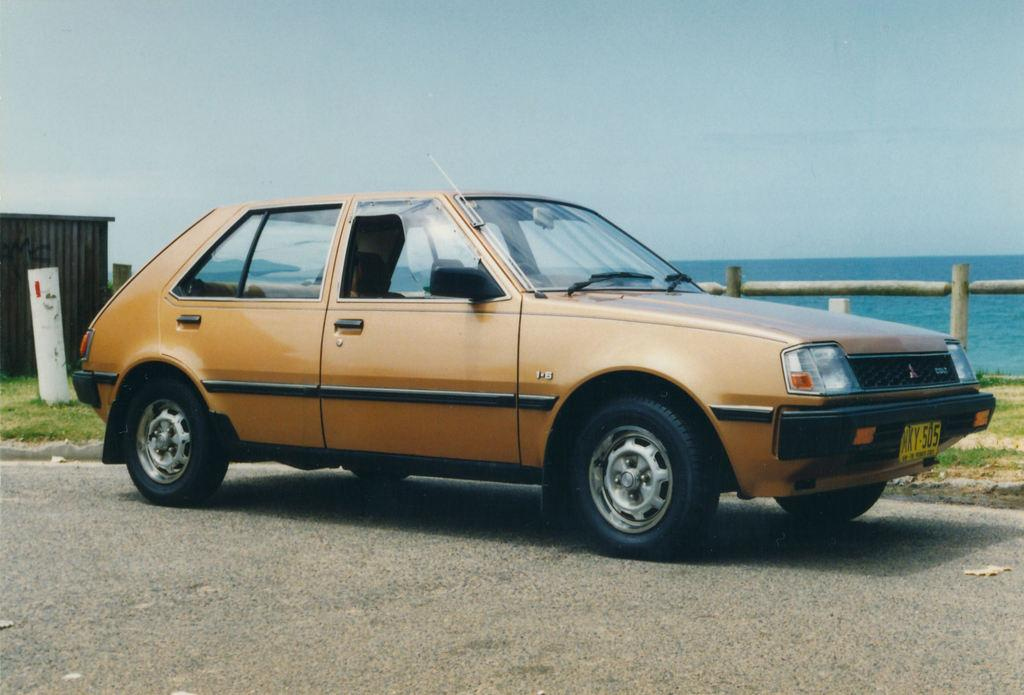What type of vehicle is on the road in the image? There is a car on the road in the image. What type of structure can be seen in the image? There is a shed in the image. What type of barrier is present in the image? There is a wooden fence in the image. What can be seen on the ground in the image? The ground is visible in the image. What natural element is visible in the image? There is water visible in the image. What part of the environment is visible in the image? The sky is visible in the image. How many toes can be seen on the car in the image? Cars do not have toes, so this question cannot be answered. 